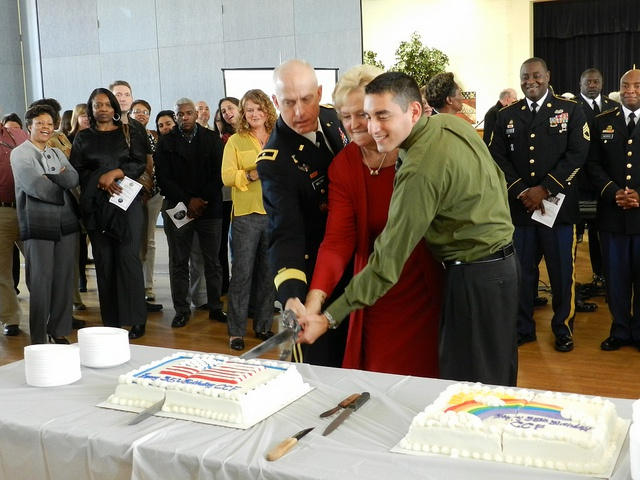Describe the objects in this image and their specific colors. I can see dining table in gray, lightgray, darkgray, beige, and tan tones, people in gray, black, darkgreen, and olive tones, people in gray, maroon, and black tones, people in gray, black, maroon, and olive tones, and people in gray, black, tan, and salmon tones in this image. 